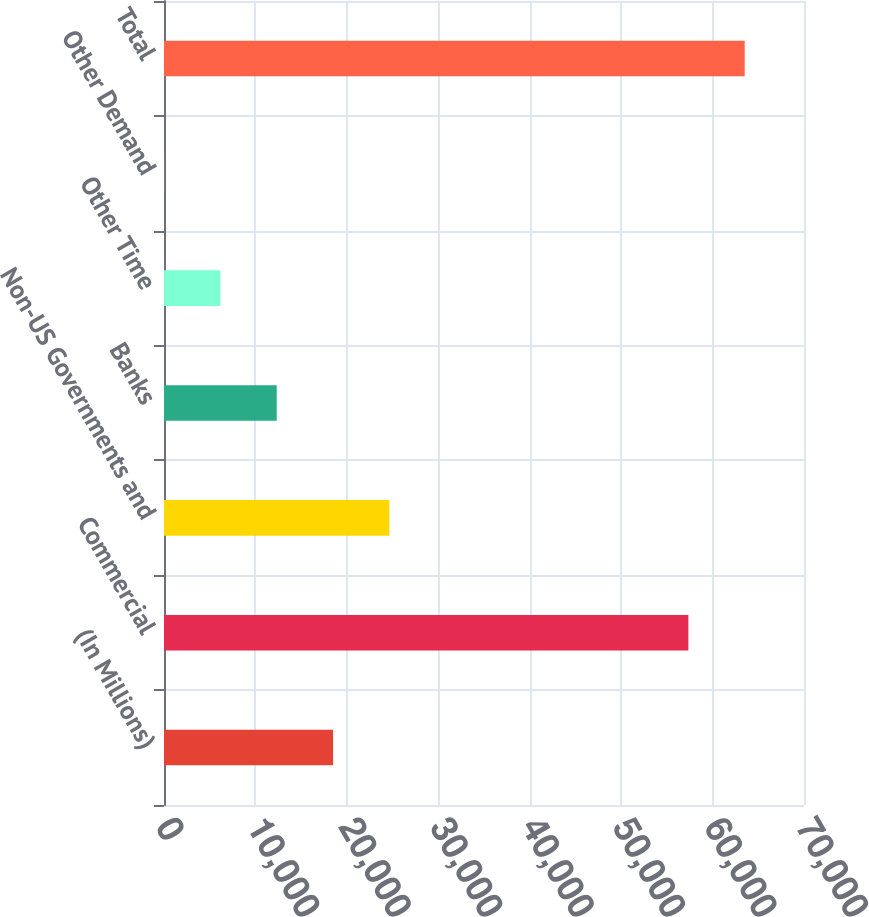Convert chart. <chart><loc_0><loc_0><loc_500><loc_500><bar_chart><fcel>(In Millions)<fcel>Commercial<fcel>Non-US Governments and<fcel>Banks<fcel>Other Time<fcel>Other Demand<fcel>Total<nl><fcel>18492.3<fcel>57354<fcel>24653.5<fcel>12331.2<fcel>6169.98<fcel>8.8<fcel>63515.2<nl></chart> 